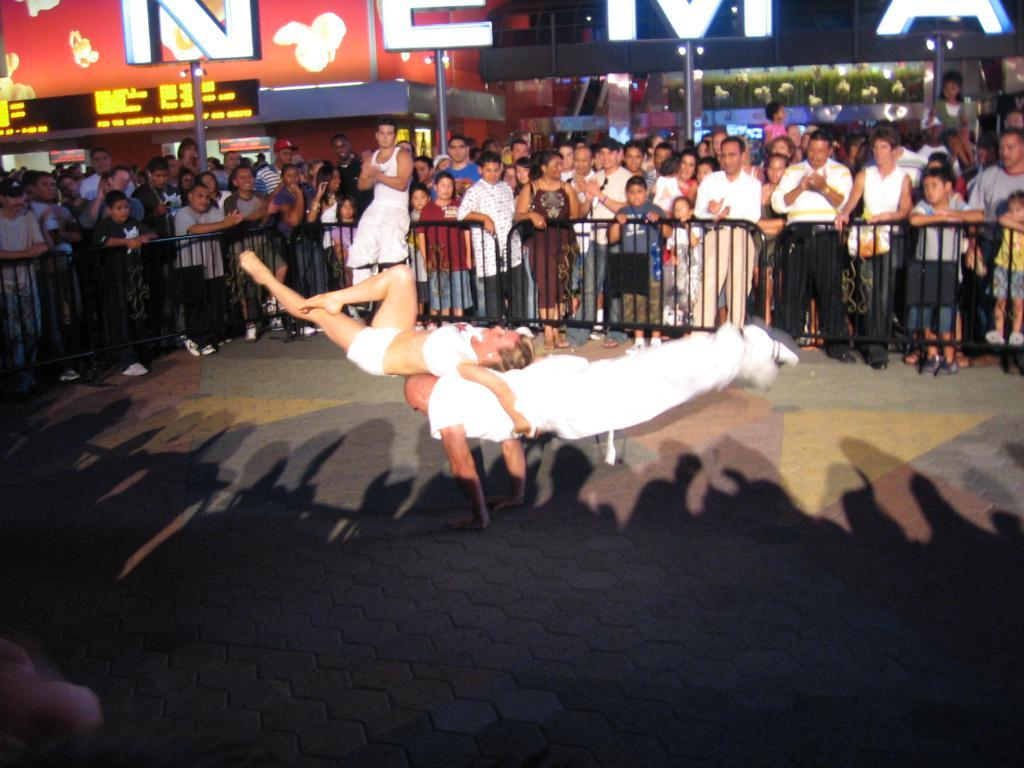What is happening on the road in the image? There are people on the road in the image. What can be seen in the background of the image? There is a fence and poles in the image. What is the name of the building visible in the image? There is a building with a name written on it in the image. What type of quill is being used to write the name on the building in the image? There is no quill present in the image; the name on the building is likely written using a modern writing instrument. How much waste is visible in the image? There is no mention of waste in the image, so it cannot be determined how much waste is visible. 